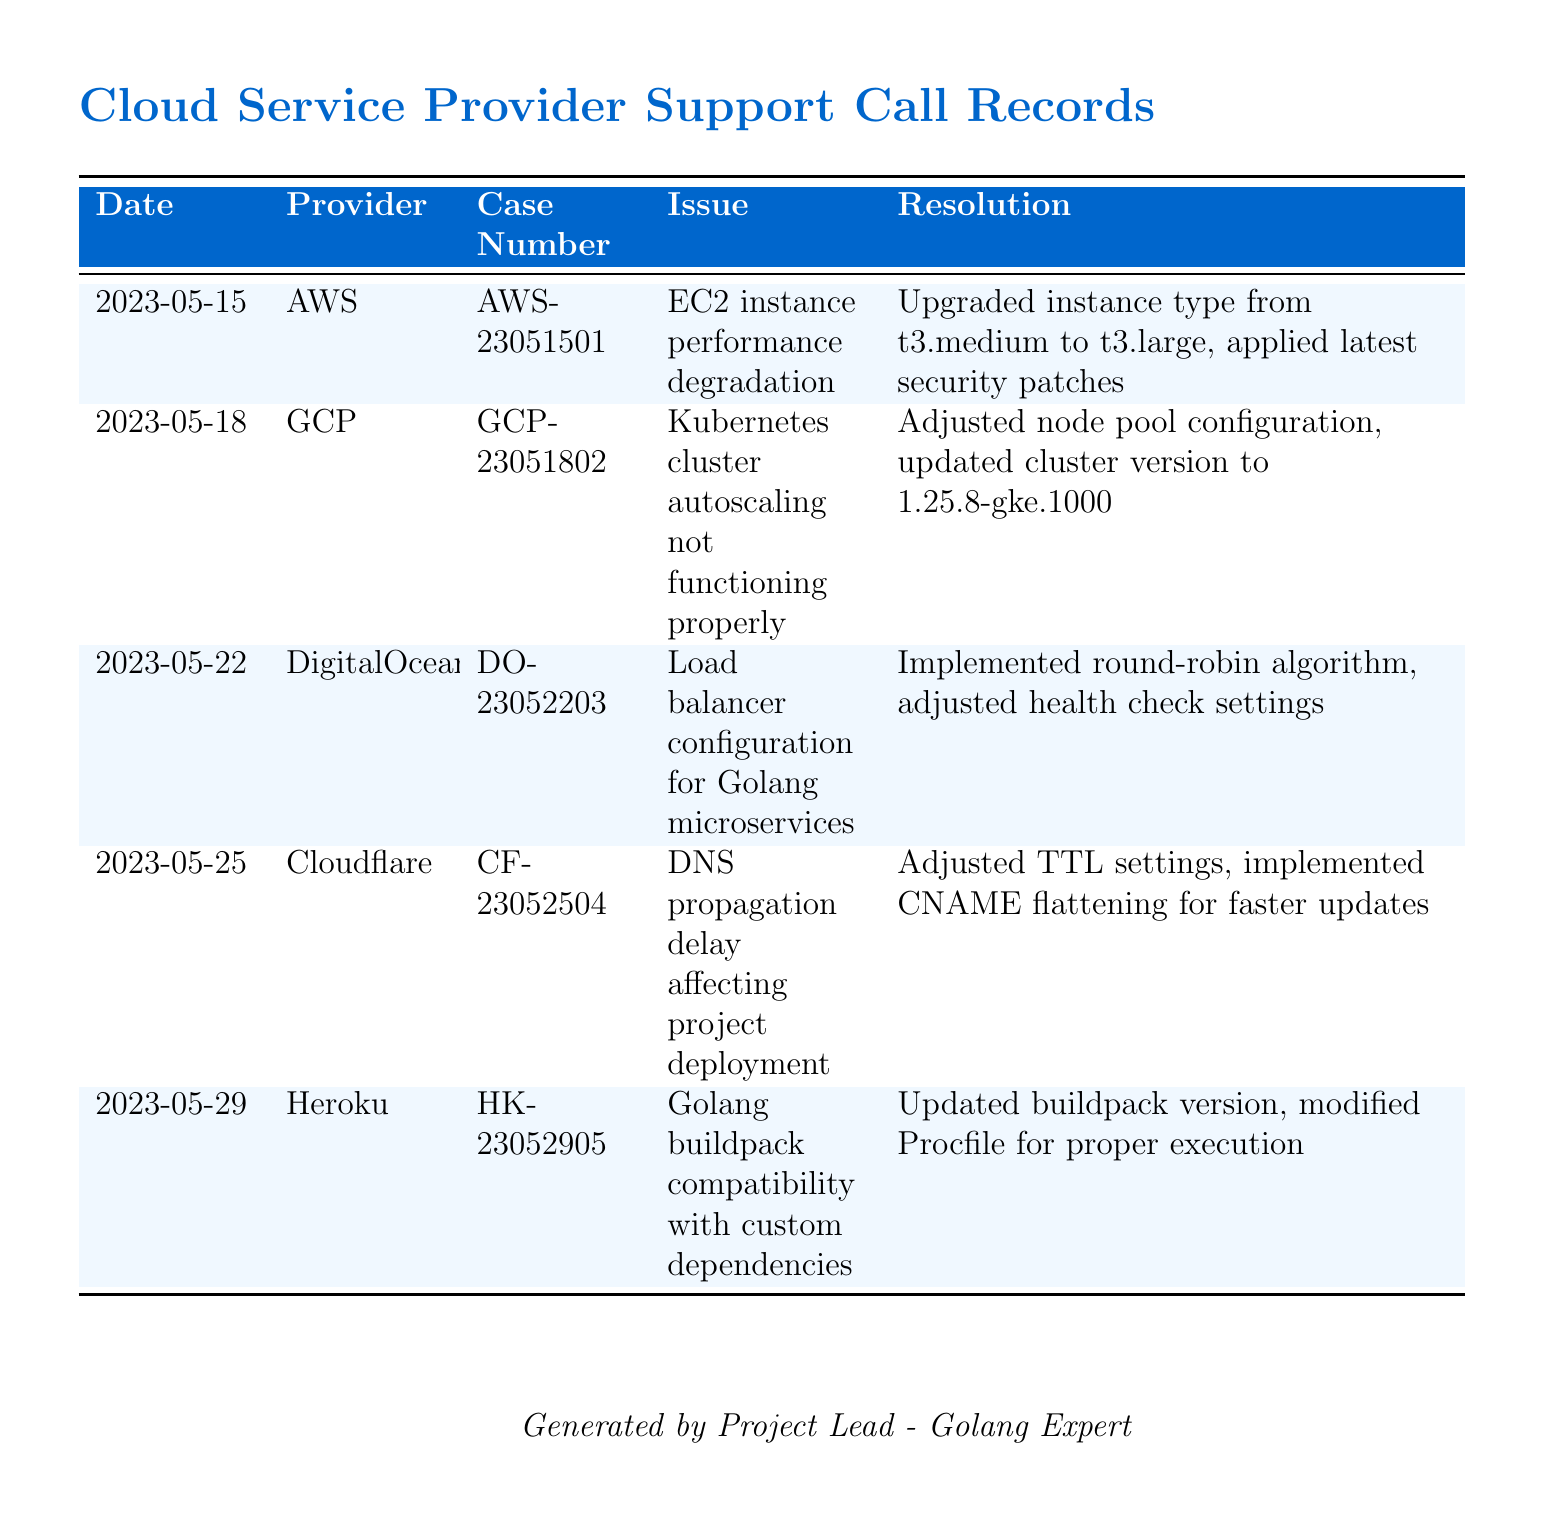What was the date of the call regarding the EC2 instance? The date listed for the EC2 instance performance degradation issue is May 15, 2023.
Answer: May 15, 2023 Which cloud provider was contacted for the DNS propagation delay issue? The provider contacted for the DNS propagation delay was Cloudflare as per the table.
Answer: Cloudflare What was the case number for the Kubernetes issue? The case number for the Kubernetes cluster autoscaling issue is GCP-23051802.
Answer: GCP-23051802 What resolution was applied to the Golang microservices issue? The resolution for the load balancer configuration issue is implementing a round-robin algorithm and adjusting health check settings.
Answer: Implemented round-robin algorithm, adjusted health check settings Which cloud service had an issue with a compatibility of Golang buildpack? The service with compatibility issues regarding the Golang buildpack was Heroku.
Answer: Heroku What version was updated for the Kubernetes cluster? The cluster version was updated to 1.25.8-gke.1000 to resolve the issue.
Answer: 1.25.8-gke.1000 How many total support calls are noted in the document? The total number of support calls listed in the document is five.
Answer: Five Which issue pertained to a performance degradation? The issue related to performance degradation was concerning the EC2 instance.
Answer: EC2 instance performance degradation 